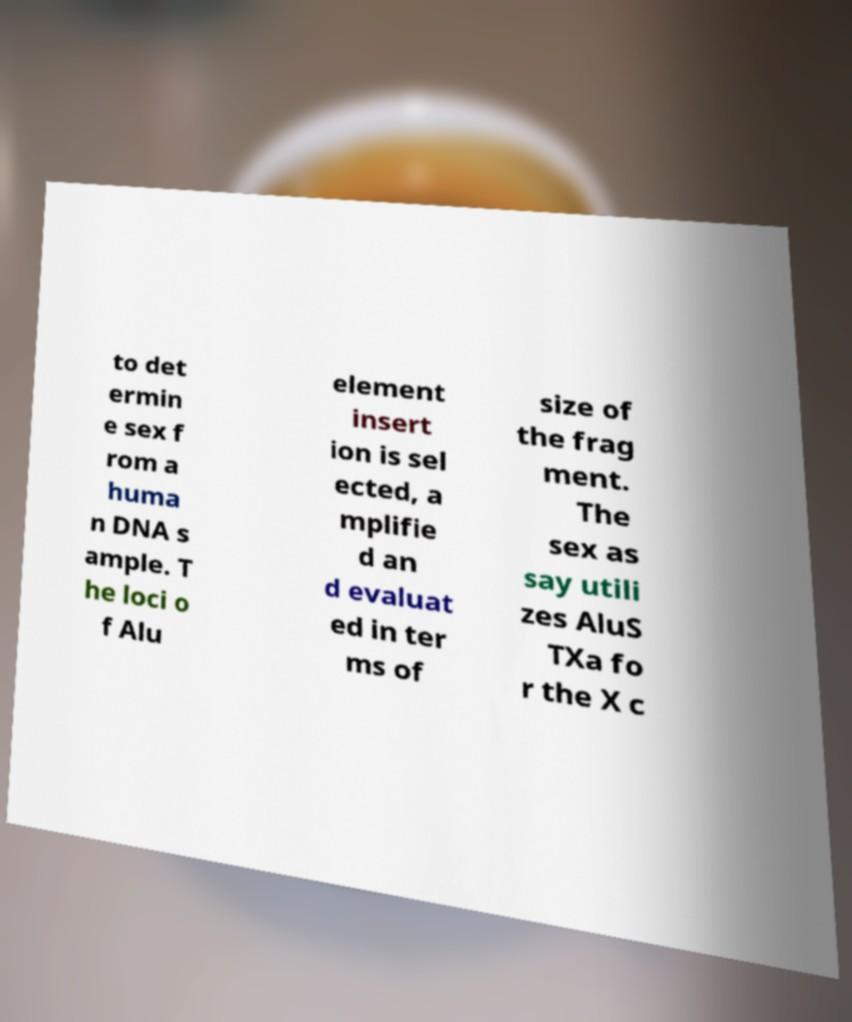Could you extract and type out the text from this image? to det ermin e sex f rom a huma n DNA s ample. T he loci o f Alu element insert ion is sel ected, a mplifie d an d evaluat ed in ter ms of size of the frag ment. The sex as say utili zes AluS TXa fo r the X c 